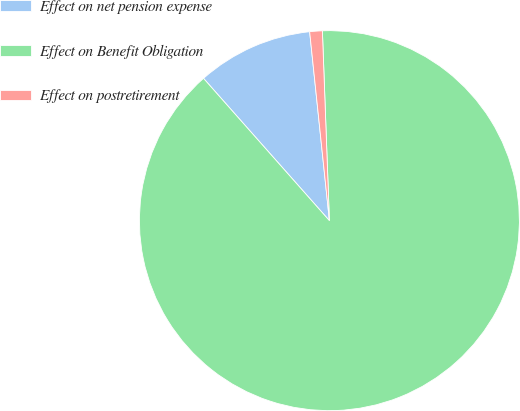Convert chart. <chart><loc_0><loc_0><loc_500><loc_500><pie_chart><fcel>Effect on net pension expense<fcel>Effect on Benefit Obligation<fcel>Effect on postretirement<nl><fcel>9.87%<fcel>89.06%<fcel>1.07%<nl></chart> 